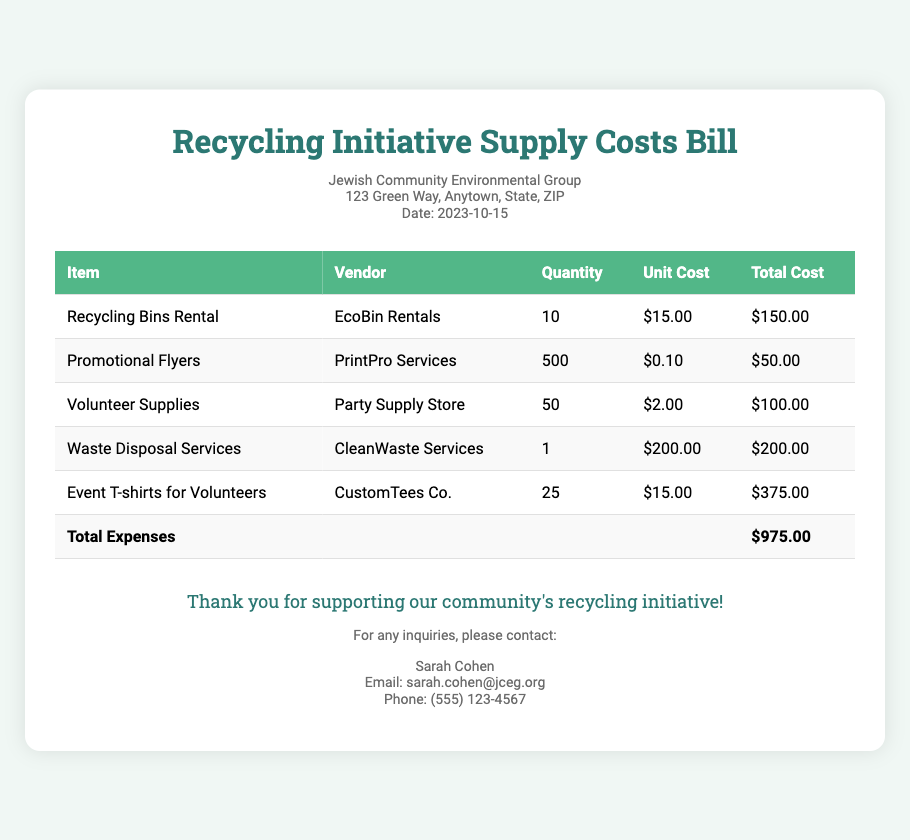what is the date of the bill? The date mentioned in the document is clearly listed in the organization information section.
Answer: 2023-10-15 who is the contact person for inquiries? The document specifies a contact person in the footer section for any inquiries related to the initiative.
Answer: Sarah Cohen how many recycling bins were rented? The total number of recycling bins rented is provided in the expenses table under 'Quantity' for the corresponding item.
Answer: 10 what is the total cost for waste disposal services? The total cost for waste disposal services is listed in the 'Total Cost' column for that specific service.
Answer: $200.00 which vendor provided the promotional flyers? The name of the vendor that supplied the promotional flyers is mentioned in the 'Vendor' column of the table.
Answer: PrintPro Services how much was spent on volunteer supplies? The total amount spent on volunteer supplies is detailed in the 'Total Cost' column for that item.
Answer: $100.00 what is the total amount of expenses? The total expenses for the recycling initiative are summarized in the last row of the expense table.
Answer: $975.00 how many event t-shirts were ordered? The number of event t-shirts ordered is indicated in the 'Quantity' column of the corresponding item in the expenses table.
Answer: 25 who rented the recycling bins? The vendor who provided the recycling bins rental is found in the 'Vendor' column next to that item.
Answer: EcoBin Rentals 